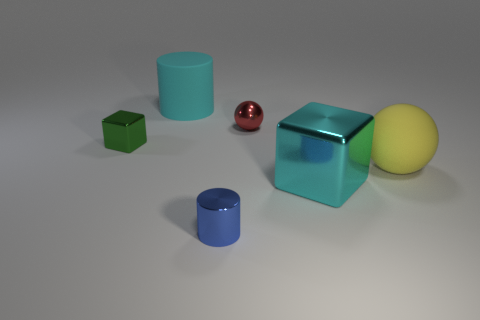Is the color of the big cylinder the same as the large cube?
Provide a succinct answer. Yes. How many rubber objects are on the left side of the yellow object?
Ensure brevity in your answer.  1. Are the cyan object on the right side of the tiny red metallic ball and the small object on the right side of the tiny cylinder made of the same material?
Provide a succinct answer. Yes. How many things are large matte things that are in front of the red metal object or yellow balls?
Keep it short and to the point. 1. Is the number of large cyan cylinders to the right of the big cylinder less than the number of objects behind the small metal block?
Provide a succinct answer. Yes. What number of other things are there of the same size as the green cube?
Provide a succinct answer. 2. Do the small cylinder and the big cyan object in front of the big yellow sphere have the same material?
Keep it short and to the point. Yes. What number of objects are either metallic things in front of the big block or things behind the blue metal object?
Offer a very short reply. 6. The large metal thing has what color?
Your response must be concise. Cyan. Are there fewer tiny balls to the right of the red thing than big cubes?
Provide a short and direct response. Yes. 